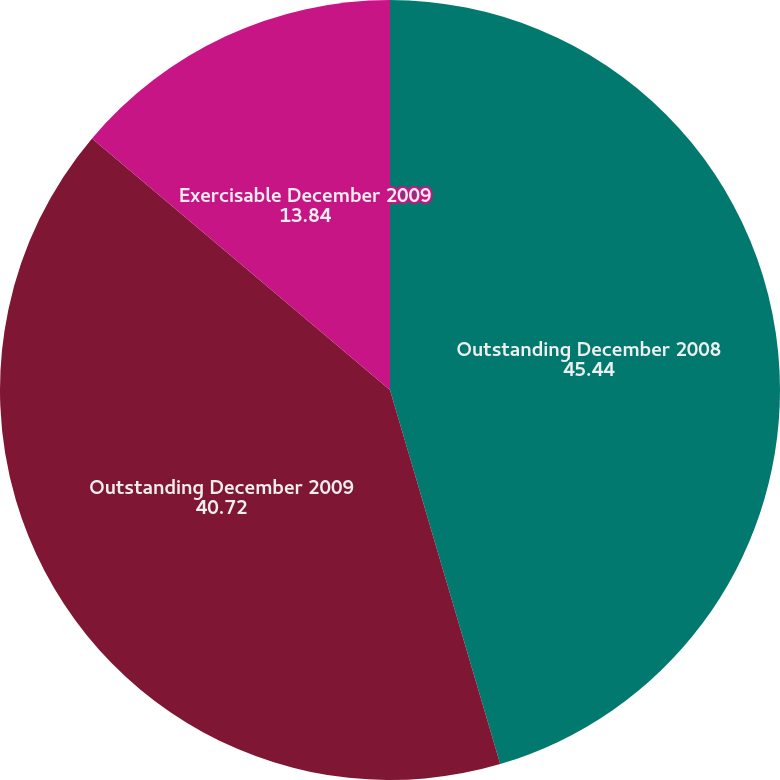Convert chart to OTSL. <chart><loc_0><loc_0><loc_500><loc_500><pie_chart><fcel>Outstanding December 2008<fcel>Outstanding December 2009<fcel>Exercisable December 2009<nl><fcel>45.44%<fcel>40.72%<fcel>13.84%<nl></chart> 